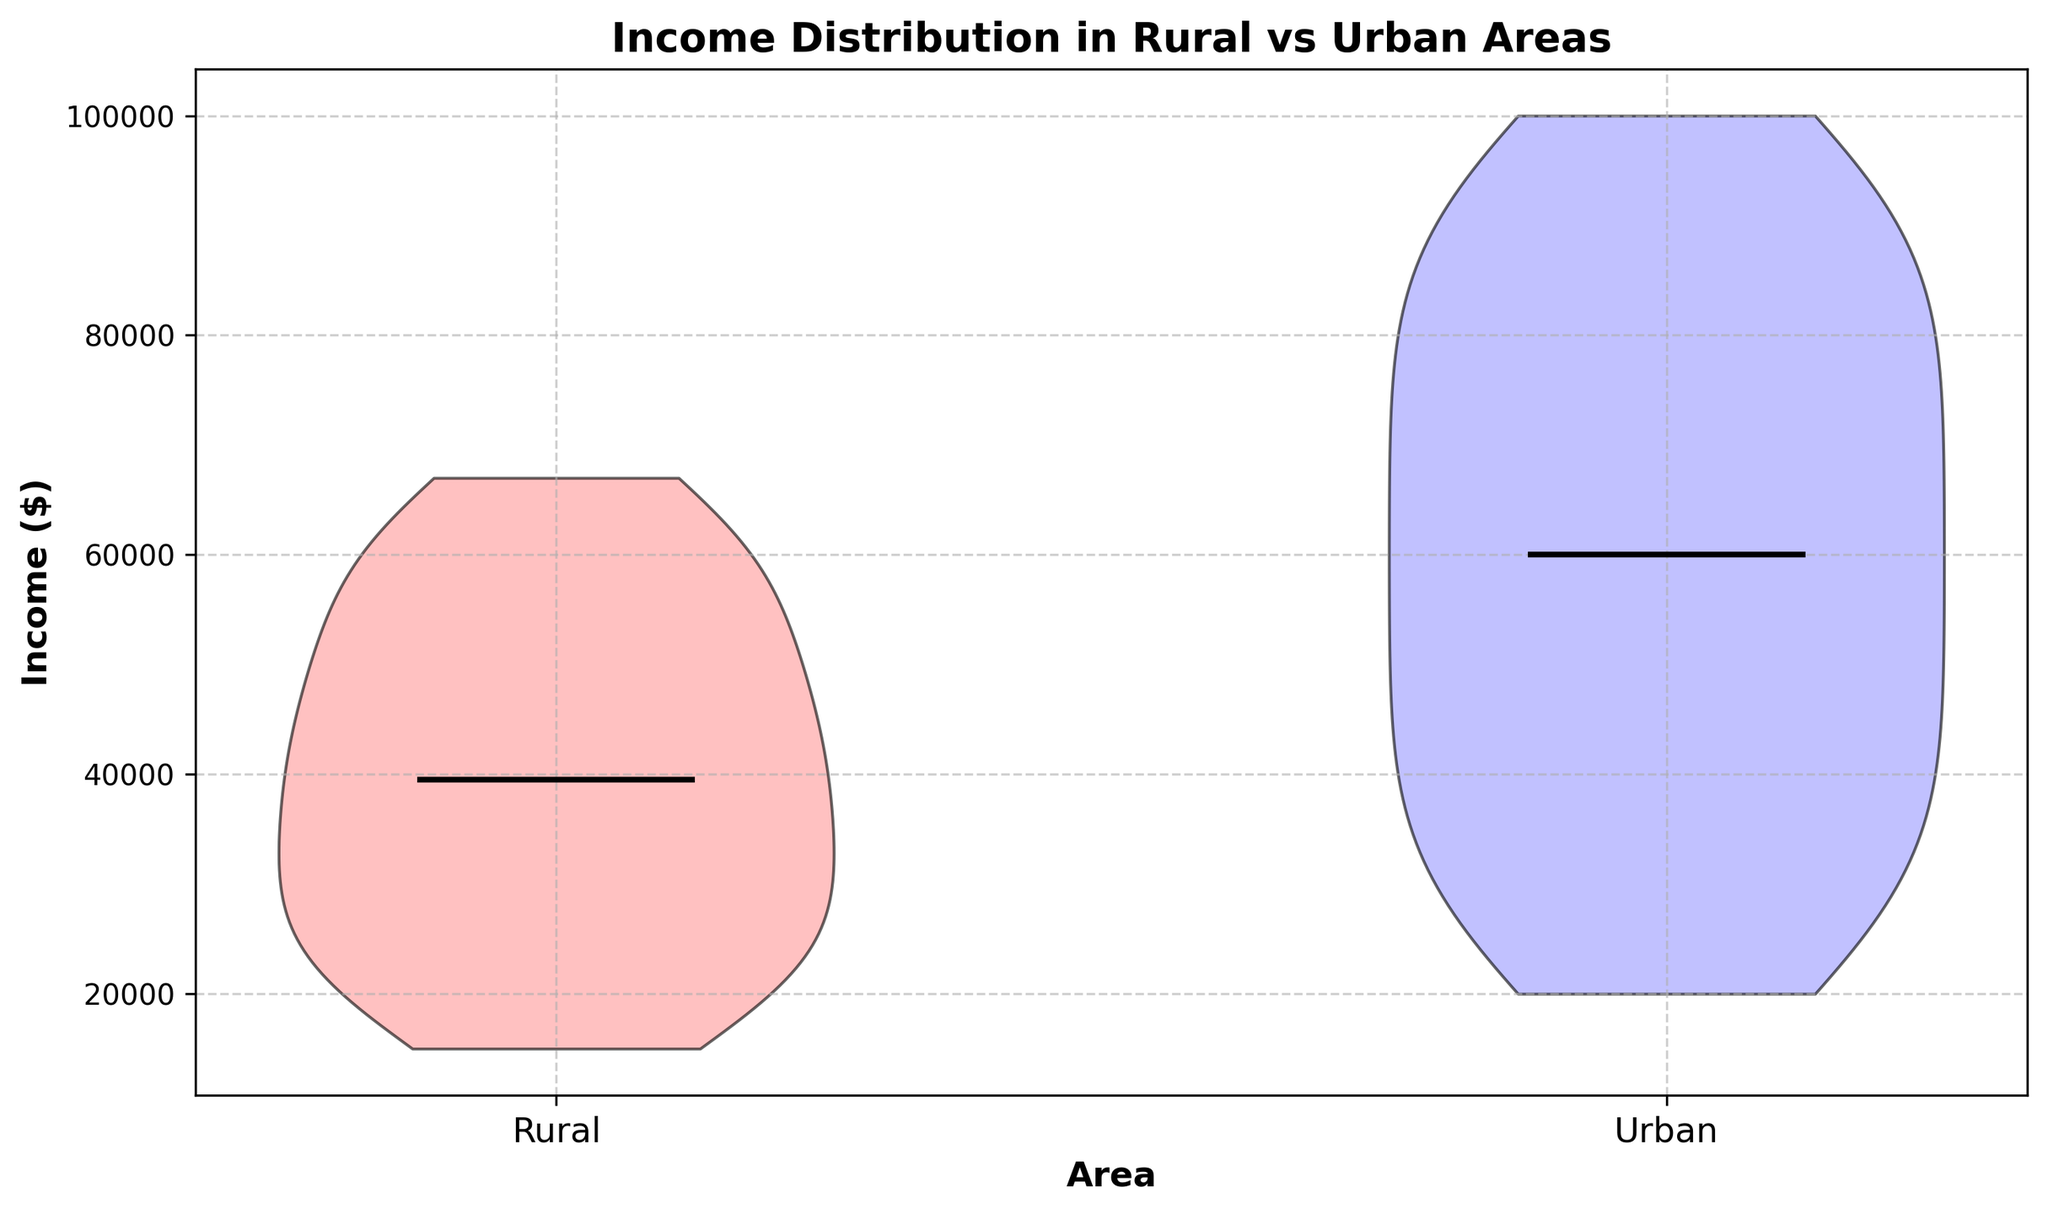What's the median income in rural areas? The black line in the violin plot represents the median value. By looking at the height where this line crosses, we determine the median income in rural areas.
Answer: 40,000 What's the median income in urban areas? The black line in the violin plot represents the median value. By looking at the height where this line crosses, we determine the median income in urban areas.
Answer: 60,000 Which area has a higher median income? Comparing the heights of the black lines representing the medians in each violin, we see that the urban area has a higher median income.
Answer: Urban What is the range of incomes in rural areas? The widest part of the violin plot extends from the lowest to the highest points, representing the range. In the rural areas, it ranges approximately from 15,000 to 67,000.
Answer: 52,000 What is the range of incomes in urban areas? The widest part of the violin plot extends from the lowest to the highest points, representing the range. In the urban areas, it ranges approximately from 20,000 to 100,000.
Answer: 80,000 Based on the plot colors, which violin represents urban areas? The blue violin represents the urban areas as indicated by its placement and the contrasting color in comparison to the red violin representing rural areas.
Answer: Blue Which area shows a greater spread in income distribution? The length of the violin from top to bottom indicates the spread. The urban area's violin, being longer, shows a greater spread in income distribution compared to the rural area.
Answer: Urban How does the average income in rural areas compare to urban areas? Generally, the rural area's violin is positioned lower, indicating a lower average income compared to the higher positioned urban area's violin.
Answer: Lower In which area are the incomes more densely concentrated around the median? The width of the violin close to the median indicates concentration. The rural violin is wider near the median compared to the urban, suggesting more density around the median income in rural areas.
Answer: Rural Is there any visual indication of outliers in either area? Neither violin plot shows any protrusions or distinctive markings that indicate outliers; both plots appear smooth and continuous, showing no visual indication of outliers.
Answer: No 